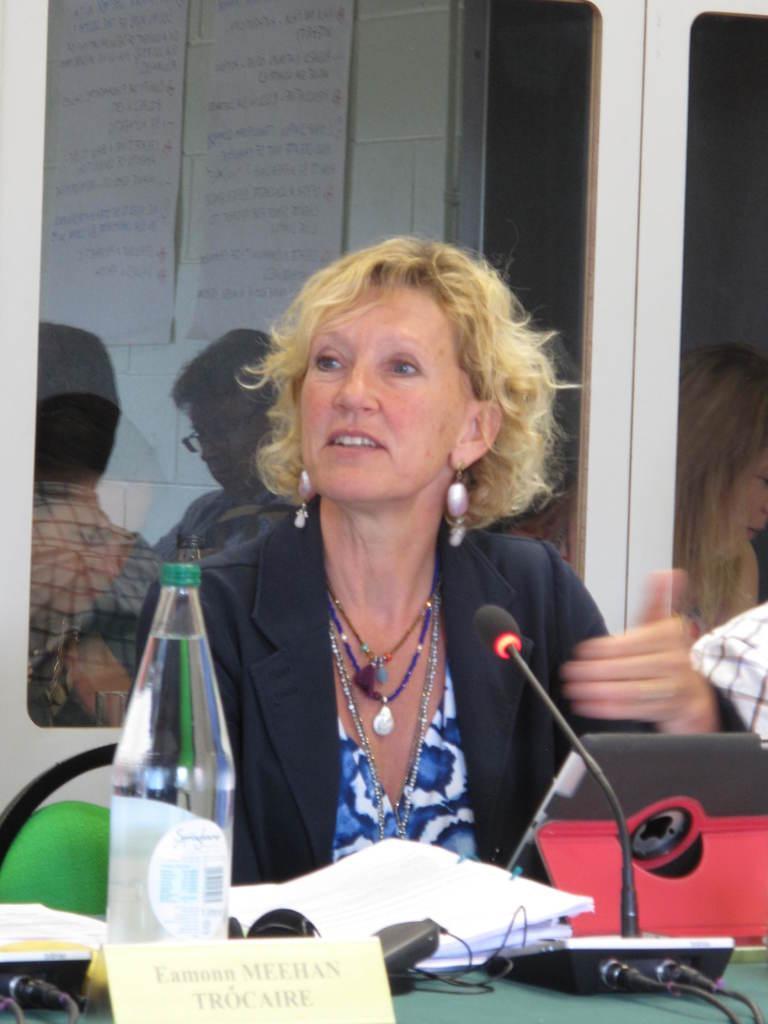Can you describe this image briefly? In this picture there is a lady at the center of the image and there is a mic in front of her, there is a water bottle, books, name plate, and head set are there on the table and there is a door at the right side of the image. 